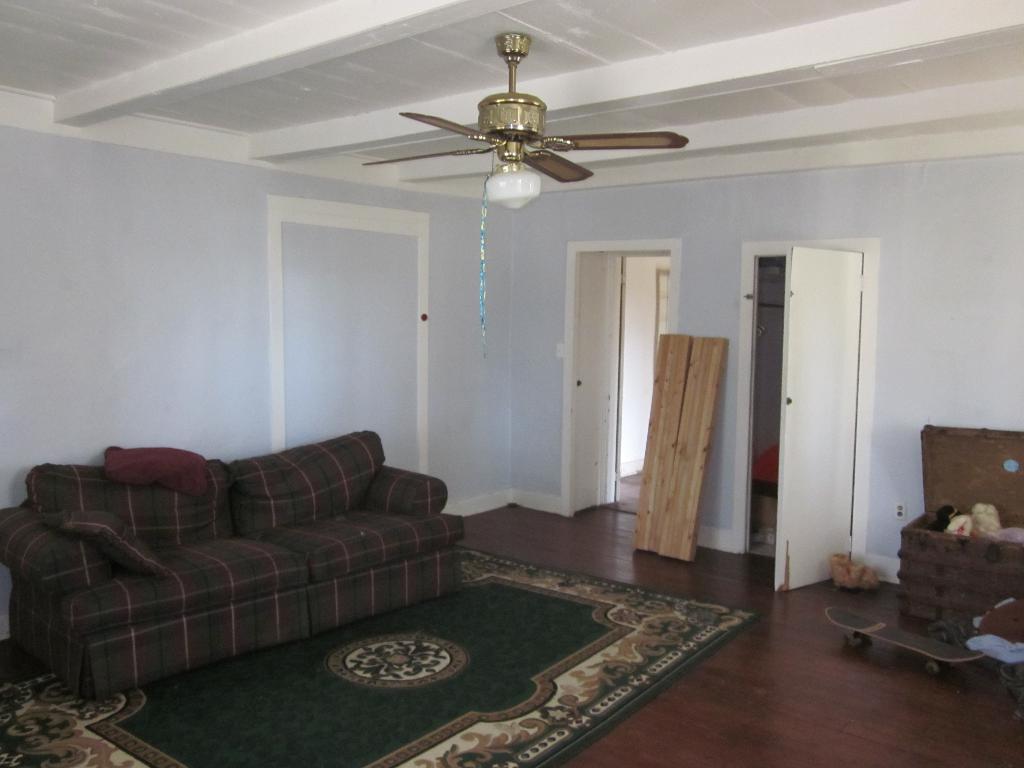Describe this image in one or two sentences. In this picture there is a room with a carpet on the floor, onto the left there is a sofa with a pillow on it, onto the right there is a box and a skate board and also a wooden plank. There is fan attached to the ceiling. 